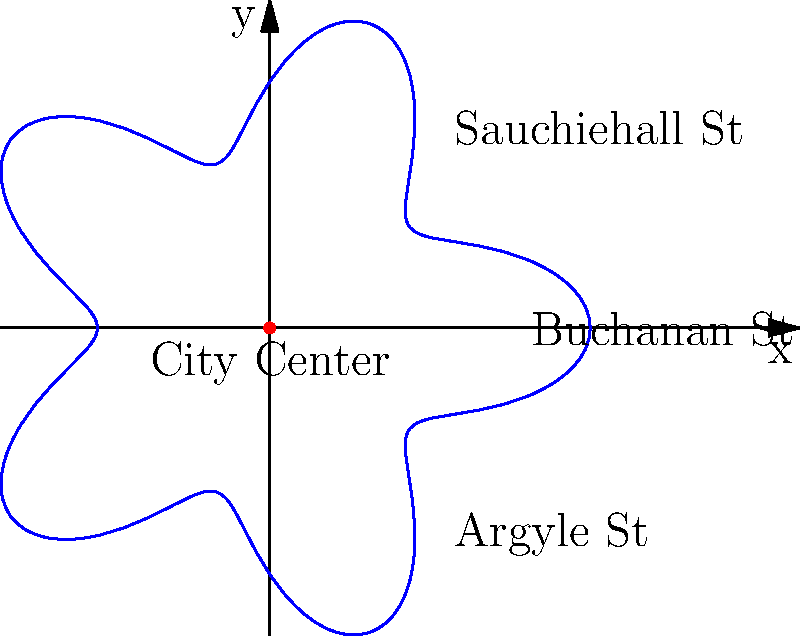As a local historian familiar with Scottish urban planning, how would you describe the relationship between the angle $\theta$ and the distance $r$ from the city center in the polar coordinate representation of Glasgow's radial street pattern shown above? To understand the relationship between $\theta$ and $r$ in the given polar coordinate representation of Glasgow's radial street pattern, let's analyze the graph step-by-step:

1. The graph shows a flower-like pattern with 5 "petals" or lobes, which represent the main radial streets emanating from the city center.

2. The equation for this pattern can be expressed as:

   $$r = 1 + 0.3 \cos(5\theta)$$

3. Breaking down this equation:
   - The constant term 1 represents the average distance from the city center.
   - 0.3 is the amplitude of the variation in distance.
   - $\cos(5\theta)$ creates the 5-fold symmetry of the pattern.

4. As $\theta$ increases from 0 to $2\pi$, the cosine function completes 5 full cycles, creating the 5 lobes.

5. When $\cos(5\theta) = 1$, $r$ is at its maximum (1.3), representing the furthest points on the main streets.

6. When $\cos(5\theta) = -1$, $r$ is at its minimum (0.7), representing the points between the main streets.

7. This pattern reflects how the distance from the city center varies as you move around it, with main streets extending further out and shorter distances between them.

In the context of Glasgow, this could represent how major radial streets like Buchanan Street, Sauchiehall Street, and Argyle Street extend further from the city center, while the areas between these main thoroughfares are closer to the center.
Answer: $r = 1 + 0.3 \cos(5\theta)$ 